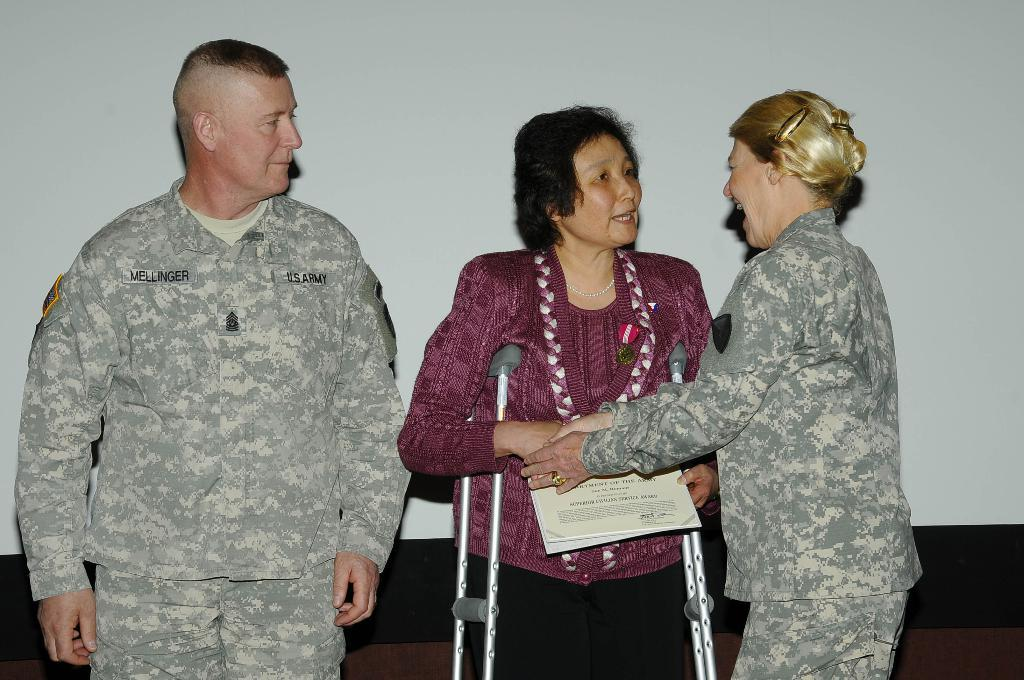How many people are present in the image? There are two women and a man in the image. What is the condition of one of the women in the image? One of the women is standing with the help of sticks. What is the woman with sticks holding? The woman with sticks is holding papers. Can you see a stream of water flowing in the background of the image? There is no stream of water visible in the image. What type of snack is being served in the image? There is no snack, such as popcorn, present in the image. 